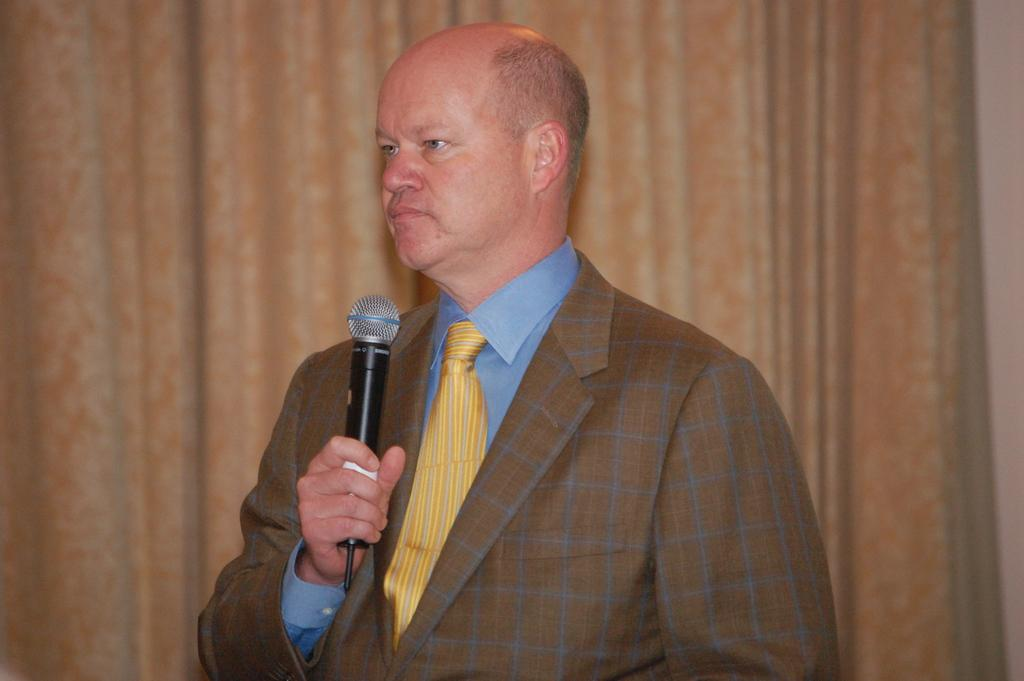What is the main subject of the image? There is a person in the image. What is the person holding in the image? The person is holding a microphone. What type of clothing is the person wearing? The person is wearing a suit and a tie. What can be seen in the background of the image? There is a curtain in the background of the image. What type of silk material is used to make the dirt visible in the image? There is no silk or dirt present in the image. 